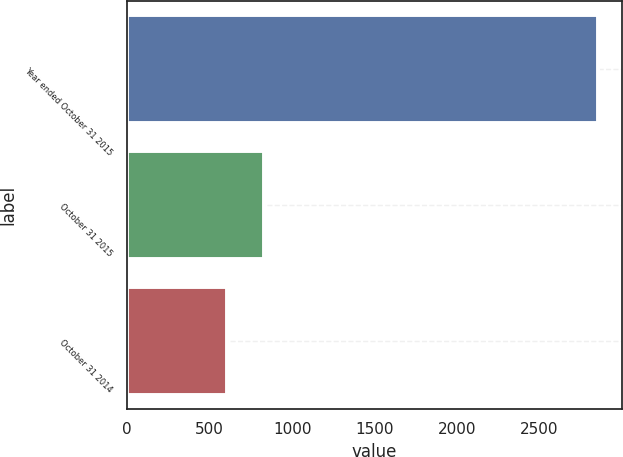<chart> <loc_0><loc_0><loc_500><loc_500><bar_chart><fcel>Year ended October 31 2015<fcel>October 31 2015<fcel>October 31 2014<nl><fcel>2856<fcel>828.3<fcel>603<nl></chart> 